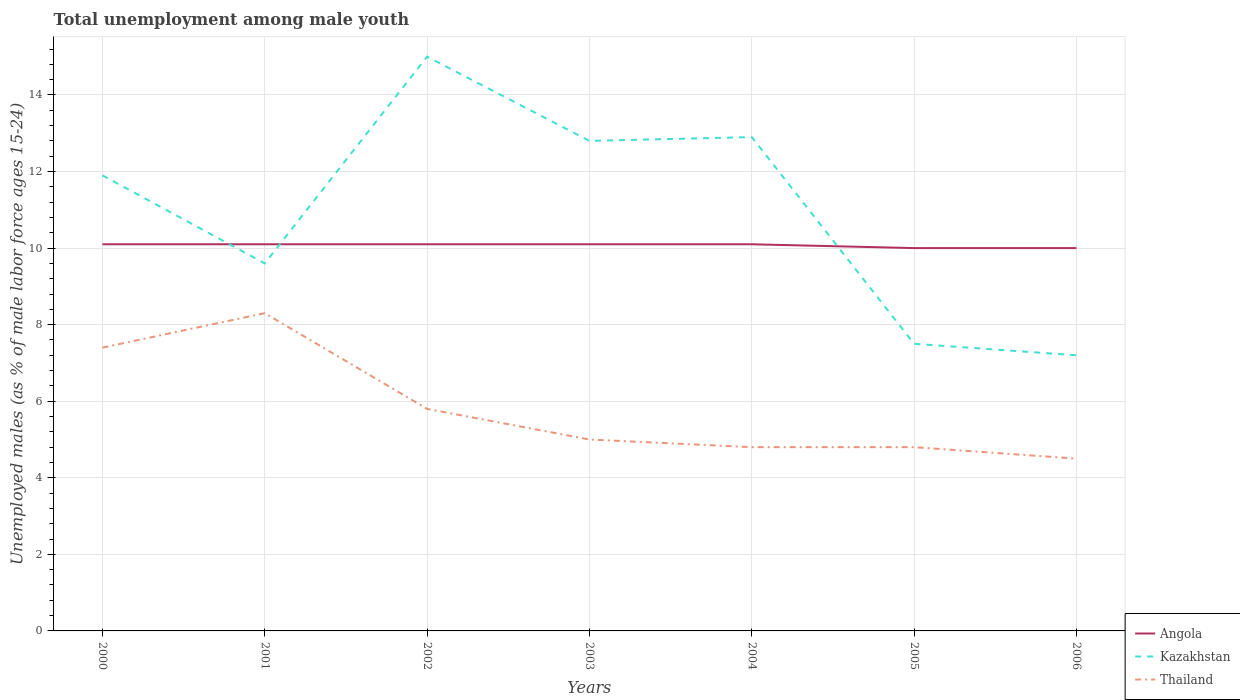How many different coloured lines are there?
Give a very brief answer. 3. Does the line corresponding to Angola intersect with the line corresponding to Thailand?
Your response must be concise. No. What is the total percentage of unemployed males in in Angola in the graph?
Make the answer very short. 0.1. What is the difference between the highest and the second highest percentage of unemployed males in in Kazakhstan?
Make the answer very short. 7.8. What is the difference between the highest and the lowest percentage of unemployed males in in Thailand?
Your answer should be compact. 3. Is the percentage of unemployed males in in Thailand strictly greater than the percentage of unemployed males in in Angola over the years?
Your answer should be very brief. Yes. Are the values on the major ticks of Y-axis written in scientific E-notation?
Ensure brevity in your answer.  No. Does the graph contain any zero values?
Keep it short and to the point. No. How many legend labels are there?
Provide a short and direct response. 3. What is the title of the graph?
Provide a short and direct response. Total unemployment among male youth. What is the label or title of the Y-axis?
Keep it short and to the point. Unemployed males (as % of male labor force ages 15-24). What is the Unemployed males (as % of male labor force ages 15-24) in Angola in 2000?
Offer a very short reply. 10.1. What is the Unemployed males (as % of male labor force ages 15-24) of Kazakhstan in 2000?
Provide a short and direct response. 11.9. What is the Unemployed males (as % of male labor force ages 15-24) in Thailand in 2000?
Provide a succinct answer. 7.4. What is the Unemployed males (as % of male labor force ages 15-24) in Angola in 2001?
Ensure brevity in your answer.  10.1. What is the Unemployed males (as % of male labor force ages 15-24) of Kazakhstan in 2001?
Your answer should be very brief. 9.6. What is the Unemployed males (as % of male labor force ages 15-24) of Thailand in 2001?
Make the answer very short. 8.3. What is the Unemployed males (as % of male labor force ages 15-24) in Angola in 2002?
Keep it short and to the point. 10.1. What is the Unemployed males (as % of male labor force ages 15-24) in Kazakhstan in 2002?
Provide a short and direct response. 15. What is the Unemployed males (as % of male labor force ages 15-24) in Thailand in 2002?
Offer a very short reply. 5.8. What is the Unemployed males (as % of male labor force ages 15-24) of Angola in 2003?
Provide a short and direct response. 10.1. What is the Unemployed males (as % of male labor force ages 15-24) in Kazakhstan in 2003?
Offer a terse response. 12.8. What is the Unemployed males (as % of male labor force ages 15-24) of Angola in 2004?
Provide a succinct answer. 10.1. What is the Unemployed males (as % of male labor force ages 15-24) in Kazakhstan in 2004?
Ensure brevity in your answer.  12.9. What is the Unemployed males (as % of male labor force ages 15-24) of Thailand in 2004?
Give a very brief answer. 4.8. What is the Unemployed males (as % of male labor force ages 15-24) in Thailand in 2005?
Keep it short and to the point. 4.8. What is the Unemployed males (as % of male labor force ages 15-24) of Angola in 2006?
Offer a very short reply. 10. What is the Unemployed males (as % of male labor force ages 15-24) in Kazakhstan in 2006?
Keep it short and to the point. 7.2. Across all years, what is the maximum Unemployed males (as % of male labor force ages 15-24) of Angola?
Offer a terse response. 10.1. Across all years, what is the maximum Unemployed males (as % of male labor force ages 15-24) in Kazakhstan?
Offer a terse response. 15. Across all years, what is the maximum Unemployed males (as % of male labor force ages 15-24) of Thailand?
Your answer should be very brief. 8.3. Across all years, what is the minimum Unemployed males (as % of male labor force ages 15-24) of Angola?
Your answer should be compact. 10. Across all years, what is the minimum Unemployed males (as % of male labor force ages 15-24) in Kazakhstan?
Ensure brevity in your answer.  7.2. Across all years, what is the minimum Unemployed males (as % of male labor force ages 15-24) of Thailand?
Provide a succinct answer. 4.5. What is the total Unemployed males (as % of male labor force ages 15-24) in Angola in the graph?
Make the answer very short. 70.5. What is the total Unemployed males (as % of male labor force ages 15-24) in Kazakhstan in the graph?
Offer a terse response. 76.9. What is the total Unemployed males (as % of male labor force ages 15-24) of Thailand in the graph?
Ensure brevity in your answer.  40.6. What is the difference between the Unemployed males (as % of male labor force ages 15-24) in Angola in 2000 and that in 2001?
Offer a terse response. 0. What is the difference between the Unemployed males (as % of male labor force ages 15-24) in Kazakhstan in 2000 and that in 2001?
Make the answer very short. 2.3. What is the difference between the Unemployed males (as % of male labor force ages 15-24) in Thailand in 2000 and that in 2001?
Give a very brief answer. -0.9. What is the difference between the Unemployed males (as % of male labor force ages 15-24) in Angola in 2000 and that in 2002?
Make the answer very short. 0. What is the difference between the Unemployed males (as % of male labor force ages 15-24) of Thailand in 2000 and that in 2002?
Offer a terse response. 1.6. What is the difference between the Unemployed males (as % of male labor force ages 15-24) in Angola in 2000 and that in 2004?
Provide a short and direct response. 0. What is the difference between the Unemployed males (as % of male labor force ages 15-24) of Kazakhstan in 2000 and that in 2004?
Provide a succinct answer. -1. What is the difference between the Unemployed males (as % of male labor force ages 15-24) in Thailand in 2000 and that in 2005?
Your response must be concise. 2.6. What is the difference between the Unemployed males (as % of male labor force ages 15-24) of Angola in 2001 and that in 2002?
Offer a terse response. 0. What is the difference between the Unemployed males (as % of male labor force ages 15-24) in Thailand in 2001 and that in 2002?
Your answer should be compact. 2.5. What is the difference between the Unemployed males (as % of male labor force ages 15-24) in Angola in 2001 and that in 2003?
Your answer should be compact. 0. What is the difference between the Unemployed males (as % of male labor force ages 15-24) of Kazakhstan in 2001 and that in 2003?
Ensure brevity in your answer.  -3.2. What is the difference between the Unemployed males (as % of male labor force ages 15-24) of Angola in 2001 and that in 2004?
Your response must be concise. 0. What is the difference between the Unemployed males (as % of male labor force ages 15-24) in Angola in 2001 and that in 2005?
Your answer should be very brief. 0.1. What is the difference between the Unemployed males (as % of male labor force ages 15-24) of Thailand in 2001 and that in 2005?
Offer a very short reply. 3.5. What is the difference between the Unemployed males (as % of male labor force ages 15-24) in Angola in 2001 and that in 2006?
Make the answer very short. 0.1. What is the difference between the Unemployed males (as % of male labor force ages 15-24) in Kazakhstan in 2001 and that in 2006?
Ensure brevity in your answer.  2.4. What is the difference between the Unemployed males (as % of male labor force ages 15-24) of Kazakhstan in 2002 and that in 2003?
Your response must be concise. 2.2. What is the difference between the Unemployed males (as % of male labor force ages 15-24) in Thailand in 2002 and that in 2003?
Keep it short and to the point. 0.8. What is the difference between the Unemployed males (as % of male labor force ages 15-24) in Angola in 2002 and that in 2005?
Provide a short and direct response. 0.1. What is the difference between the Unemployed males (as % of male labor force ages 15-24) in Kazakhstan in 2002 and that in 2006?
Your answer should be compact. 7.8. What is the difference between the Unemployed males (as % of male labor force ages 15-24) of Thailand in 2003 and that in 2004?
Your answer should be compact. 0.2. What is the difference between the Unemployed males (as % of male labor force ages 15-24) of Kazakhstan in 2003 and that in 2005?
Give a very brief answer. 5.3. What is the difference between the Unemployed males (as % of male labor force ages 15-24) of Angola in 2003 and that in 2006?
Make the answer very short. 0.1. What is the difference between the Unemployed males (as % of male labor force ages 15-24) in Kazakhstan in 2003 and that in 2006?
Make the answer very short. 5.6. What is the difference between the Unemployed males (as % of male labor force ages 15-24) of Kazakhstan in 2004 and that in 2006?
Your answer should be compact. 5.7. What is the difference between the Unemployed males (as % of male labor force ages 15-24) of Thailand in 2004 and that in 2006?
Provide a succinct answer. 0.3. What is the difference between the Unemployed males (as % of male labor force ages 15-24) in Thailand in 2005 and that in 2006?
Offer a terse response. 0.3. What is the difference between the Unemployed males (as % of male labor force ages 15-24) of Angola in 2000 and the Unemployed males (as % of male labor force ages 15-24) of Kazakhstan in 2001?
Make the answer very short. 0.5. What is the difference between the Unemployed males (as % of male labor force ages 15-24) in Angola in 2000 and the Unemployed males (as % of male labor force ages 15-24) in Thailand in 2002?
Offer a terse response. 4.3. What is the difference between the Unemployed males (as % of male labor force ages 15-24) of Kazakhstan in 2000 and the Unemployed males (as % of male labor force ages 15-24) of Thailand in 2003?
Your answer should be compact. 6.9. What is the difference between the Unemployed males (as % of male labor force ages 15-24) of Kazakhstan in 2000 and the Unemployed males (as % of male labor force ages 15-24) of Thailand in 2004?
Provide a succinct answer. 7.1. What is the difference between the Unemployed males (as % of male labor force ages 15-24) in Angola in 2000 and the Unemployed males (as % of male labor force ages 15-24) in Kazakhstan in 2005?
Make the answer very short. 2.6. What is the difference between the Unemployed males (as % of male labor force ages 15-24) in Kazakhstan in 2000 and the Unemployed males (as % of male labor force ages 15-24) in Thailand in 2005?
Your answer should be very brief. 7.1. What is the difference between the Unemployed males (as % of male labor force ages 15-24) in Angola in 2000 and the Unemployed males (as % of male labor force ages 15-24) in Thailand in 2006?
Offer a very short reply. 5.6. What is the difference between the Unemployed males (as % of male labor force ages 15-24) of Angola in 2001 and the Unemployed males (as % of male labor force ages 15-24) of Kazakhstan in 2002?
Your response must be concise. -4.9. What is the difference between the Unemployed males (as % of male labor force ages 15-24) in Kazakhstan in 2001 and the Unemployed males (as % of male labor force ages 15-24) in Thailand in 2002?
Your response must be concise. 3.8. What is the difference between the Unemployed males (as % of male labor force ages 15-24) in Angola in 2001 and the Unemployed males (as % of male labor force ages 15-24) in Kazakhstan in 2003?
Provide a short and direct response. -2.7. What is the difference between the Unemployed males (as % of male labor force ages 15-24) of Angola in 2001 and the Unemployed males (as % of male labor force ages 15-24) of Thailand in 2003?
Ensure brevity in your answer.  5.1. What is the difference between the Unemployed males (as % of male labor force ages 15-24) of Kazakhstan in 2001 and the Unemployed males (as % of male labor force ages 15-24) of Thailand in 2003?
Offer a very short reply. 4.6. What is the difference between the Unemployed males (as % of male labor force ages 15-24) in Angola in 2001 and the Unemployed males (as % of male labor force ages 15-24) in Kazakhstan in 2004?
Your response must be concise. -2.8. What is the difference between the Unemployed males (as % of male labor force ages 15-24) of Kazakhstan in 2001 and the Unemployed males (as % of male labor force ages 15-24) of Thailand in 2004?
Your answer should be compact. 4.8. What is the difference between the Unemployed males (as % of male labor force ages 15-24) in Kazakhstan in 2001 and the Unemployed males (as % of male labor force ages 15-24) in Thailand in 2005?
Provide a short and direct response. 4.8. What is the difference between the Unemployed males (as % of male labor force ages 15-24) of Angola in 2001 and the Unemployed males (as % of male labor force ages 15-24) of Thailand in 2006?
Provide a succinct answer. 5.6. What is the difference between the Unemployed males (as % of male labor force ages 15-24) in Kazakhstan in 2001 and the Unemployed males (as % of male labor force ages 15-24) in Thailand in 2006?
Provide a succinct answer. 5.1. What is the difference between the Unemployed males (as % of male labor force ages 15-24) of Angola in 2002 and the Unemployed males (as % of male labor force ages 15-24) of Kazakhstan in 2004?
Provide a succinct answer. -2.8. What is the difference between the Unemployed males (as % of male labor force ages 15-24) of Angola in 2002 and the Unemployed males (as % of male labor force ages 15-24) of Thailand in 2005?
Make the answer very short. 5.3. What is the difference between the Unemployed males (as % of male labor force ages 15-24) of Kazakhstan in 2002 and the Unemployed males (as % of male labor force ages 15-24) of Thailand in 2005?
Your answer should be very brief. 10.2. What is the difference between the Unemployed males (as % of male labor force ages 15-24) of Angola in 2003 and the Unemployed males (as % of male labor force ages 15-24) of Thailand in 2004?
Provide a succinct answer. 5.3. What is the difference between the Unemployed males (as % of male labor force ages 15-24) in Kazakhstan in 2003 and the Unemployed males (as % of male labor force ages 15-24) in Thailand in 2004?
Your answer should be very brief. 8. What is the difference between the Unemployed males (as % of male labor force ages 15-24) of Angola in 2003 and the Unemployed males (as % of male labor force ages 15-24) of Kazakhstan in 2005?
Ensure brevity in your answer.  2.6. What is the difference between the Unemployed males (as % of male labor force ages 15-24) in Kazakhstan in 2003 and the Unemployed males (as % of male labor force ages 15-24) in Thailand in 2005?
Offer a terse response. 8. What is the difference between the Unemployed males (as % of male labor force ages 15-24) in Angola in 2003 and the Unemployed males (as % of male labor force ages 15-24) in Thailand in 2006?
Provide a succinct answer. 5.6. What is the difference between the Unemployed males (as % of male labor force ages 15-24) of Angola in 2004 and the Unemployed males (as % of male labor force ages 15-24) of Kazakhstan in 2005?
Your answer should be very brief. 2.6. What is the difference between the Unemployed males (as % of male labor force ages 15-24) in Angola in 2004 and the Unemployed males (as % of male labor force ages 15-24) in Thailand in 2005?
Ensure brevity in your answer.  5.3. What is the difference between the Unemployed males (as % of male labor force ages 15-24) of Kazakhstan in 2004 and the Unemployed males (as % of male labor force ages 15-24) of Thailand in 2005?
Ensure brevity in your answer.  8.1. What is the difference between the Unemployed males (as % of male labor force ages 15-24) in Angola in 2004 and the Unemployed males (as % of male labor force ages 15-24) in Kazakhstan in 2006?
Provide a succinct answer. 2.9. What is the difference between the Unemployed males (as % of male labor force ages 15-24) in Angola in 2004 and the Unemployed males (as % of male labor force ages 15-24) in Thailand in 2006?
Make the answer very short. 5.6. What is the difference between the Unemployed males (as % of male labor force ages 15-24) of Angola in 2005 and the Unemployed males (as % of male labor force ages 15-24) of Thailand in 2006?
Offer a terse response. 5.5. What is the average Unemployed males (as % of male labor force ages 15-24) of Angola per year?
Keep it short and to the point. 10.07. What is the average Unemployed males (as % of male labor force ages 15-24) in Kazakhstan per year?
Give a very brief answer. 10.99. What is the average Unemployed males (as % of male labor force ages 15-24) of Thailand per year?
Offer a very short reply. 5.8. In the year 2000, what is the difference between the Unemployed males (as % of male labor force ages 15-24) in Angola and Unemployed males (as % of male labor force ages 15-24) in Kazakhstan?
Keep it short and to the point. -1.8. In the year 2000, what is the difference between the Unemployed males (as % of male labor force ages 15-24) in Angola and Unemployed males (as % of male labor force ages 15-24) in Thailand?
Provide a succinct answer. 2.7. In the year 2001, what is the difference between the Unemployed males (as % of male labor force ages 15-24) in Angola and Unemployed males (as % of male labor force ages 15-24) in Kazakhstan?
Provide a short and direct response. 0.5. In the year 2001, what is the difference between the Unemployed males (as % of male labor force ages 15-24) in Kazakhstan and Unemployed males (as % of male labor force ages 15-24) in Thailand?
Offer a terse response. 1.3. In the year 2002, what is the difference between the Unemployed males (as % of male labor force ages 15-24) of Kazakhstan and Unemployed males (as % of male labor force ages 15-24) of Thailand?
Ensure brevity in your answer.  9.2. In the year 2003, what is the difference between the Unemployed males (as % of male labor force ages 15-24) in Angola and Unemployed males (as % of male labor force ages 15-24) in Thailand?
Give a very brief answer. 5.1. In the year 2004, what is the difference between the Unemployed males (as % of male labor force ages 15-24) of Angola and Unemployed males (as % of male labor force ages 15-24) of Kazakhstan?
Ensure brevity in your answer.  -2.8. In the year 2004, what is the difference between the Unemployed males (as % of male labor force ages 15-24) in Angola and Unemployed males (as % of male labor force ages 15-24) in Thailand?
Offer a very short reply. 5.3. In the year 2004, what is the difference between the Unemployed males (as % of male labor force ages 15-24) of Kazakhstan and Unemployed males (as % of male labor force ages 15-24) of Thailand?
Your response must be concise. 8.1. In the year 2005, what is the difference between the Unemployed males (as % of male labor force ages 15-24) in Angola and Unemployed males (as % of male labor force ages 15-24) in Kazakhstan?
Offer a terse response. 2.5. In the year 2005, what is the difference between the Unemployed males (as % of male labor force ages 15-24) in Kazakhstan and Unemployed males (as % of male labor force ages 15-24) in Thailand?
Offer a very short reply. 2.7. In the year 2006, what is the difference between the Unemployed males (as % of male labor force ages 15-24) in Angola and Unemployed males (as % of male labor force ages 15-24) in Kazakhstan?
Your response must be concise. 2.8. In the year 2006, what is the difference between the Unemployed males (as % of male labor force ages 15-24) of Angola and Unemployed males (as % of male labor force ages 15-24) of Thailand?
Provide a short and direct response. 5.5. In the year 2006, what is the difference between the Unemployed males (as % of male labor force ages 15-24) in Kazakhstan and Unemployed males (as % of male labor force ages 15-24) in Thailand?
Provide a short and direct response. 2.7. What is the ratio of the Unemployed males (as % of male labor force ages 15-24) in Angola in 2000 to that in 2001?
Your answer should be very brief. 1. What is the ratio of the Unemployed males (as % of male labor force ages 15-24) in Kazakhstan in 2000 to that in 2001?
Offer a very short reply. 1.24. What is the ratio of the Unemployed males (as % of male labor force ages 15-24) of Thailand in 2000 to that in 2001?
Provide a succinct answer. 0.89. What is the ratio of the Unemployed males (as % of male labor force ages 15-24) in Kazakhstan in 2000 to that in 2002?
Give a very brief answer. 0.79. What is the ratio of the Unemployed males (as % of male labor force ages 15-24) in Thailand in 2000 to that in 2002?
Your response must be concise. 1.28. What is the ratio of the Unemployed males (as % of male labor force ages 15-24) in Kazakhstan in 2000 to that in 2003?
Your response must be concise. 0.93. What is the ratio of the Unemployed males (as % of male labor force ages 15-24) of Thailand in 2000 to that in 2003?
Offer a terse response. 1.48. What is the ratio of the Unemployed males (as % of male labor force ages 15-24) of Kazakhstan in 2000 to that in 2004?
Keep it short and to the point. 0.92. What is the ratio of the Unemployed males (as % of male labor force ages 15-24) of Thailand in 2000 to that in 2004?
Make the answer very short. 1.54. What is the ratio of the Unemployed males (as % of male labor force ages 15-24) in Kazakhstan in 2000 to that in 2005?
Give a very brief answer. 1.59. What is the ratio of the Unemployed males (as % of male labor force ages 15-24) of Thailand in 2000 to that in 2005?
Your answer should be very brief. 1.54. What is the ratio of the Unemployed males (as % of male labor force ages 15-24) of Kazakhstan in 2000 to that in 2006?
Offer a terse response. 1.65. What is the ratio of the Unemployed males (as % of male labor force ages 15-24) in Thailand in 2000 to that in 2006?
Ensure brevity in your answer.  1.64. What is the ratio of the Unemployed males (as % of male labor force ages 15-24) in Angola in 2001 to that in 2002?
Keep it short and to the point. 1. What is the ratio of the Unemployed males (as % of male labor force ages 15-24) in Kazakhstan in 2001 to that in 2002?
Offer a very short reply. 0.64. What is the ratio of the Unemployed males (as % of male labor force ages 15-24) in Thailand in 2001 to that in 2002?
Make the answer very short. 1.43. What is the ratio of the Unemployed males (as % of male labor force ages 15-24) of Thailand in 2001 to that in 2003?
Offer a terse response. 1.66. What is the ratio of the Unemployed males (as % of male labor force ages 15-24) of Kazakhstan in 2001 to that in 2004?
Your answer should be compact. 0.74. What is the ratio of the Unemployed males (as % of male labor force ages 15-24) of Thailand in 2001 to that in 2004?
Ensure brevity in your answer.  1.73. What is the ratio of the Unemployed males (as % of male labor force ages 15-24) in Kazakhstan in 2001 to that in 2005?
Your answer should be very brief. 1.28. What is the ratio of the Unemployed males (as % of male labor force ages 15-24) of Thailand in 2001 to that in 2005?
Provide a short and direct response. 1.73. What is the ratio of the Unemployed males (as % of male labor force ages 15-24) in Angola in 2001 to that in 2006?
Ensure brevity in your answer.  1.01. What is the ratio of the Unemployed males (as % of male labor force ages 15-24) of Thailand in 2001 to that in 2006?
Your answer should be very brief. 1.84. What is the ratio of the Unemployed males (as % of male labor force ages 15-24) of Angola in 2002 to that in 2003?
Offer a very short reply. 1. What is the ratio of the Unemployed males (as % of male labor force ages 15-24) of Kazakhstan in 2002 to that in 2003?
Your answer should be compact. 1.17. What is the ratio of the Unemployed males (as % of male labor force ages 15-24) in Thailand in 2002 to that in 2003?
Ensure brevity in your answer.  1.16. What is the ratio of the Unemployed males (as % of male labor force ages 15-24) in Kazakhstan in 2002 to that in 2004?
Your response must be concise. 1.16. What is the ratio of the Unemployed males (as % of male labor force ages 15-24) of Thailand in 2002 to that in 2004?
Offer a very short reply. 1.21. What is the ratio of the Unemployed males (as % of male labor force ages 15-24) of Kazakhstan in 2002 to that in 2005?
Offer a terse response. 2. What is the ratio of the Unemployed males (as % of male labor force ages 15-24) of Thailand in 2002 to that in 2005?
Ensure brevity in your answer.  1.21. What is the ratio of the Unemployed males (as % of male labor force ages 15-24) in Angola in 2002 to that in 2006?
Keep it short and to the point. 1.01. What is the ratio of the Unemployed males (as % of male labor force ages 15-24) in Kazakhstan in 2002 to that in 2006?
Give a very brief answer. 2.08. What is the ratio of the Unemployed males (as % of male labor force ages 15-24) of Thailand in 2002 to that in 2006?
Provide a short and direct response. 1.29. What is the ratio of the Unemployed males (as % of male labor force ages 15-24) of Angola in 2003 to that in 2004?
Keep it short and to the point. 1. What is the ratio of the Unemployed males (as % of male labor force ages 15-24) in Thailand in 2003 to that in 2004?
Keep it short and to the point. 1.04. What is the ratio of the Unemployed males (as % of male labor force ages 15-24) of Kazakhstan in 2003 to that in 2005?
Ensure brevity in your answer.  1.71. What is the ratio of the Unemployed males (as % of male labor force ages 15-24) of Thailand in 2003 to that in 2005?
Your answer should be very brief. 1.04. What is the ratio of the Unemployed males (as % of male labor force ages 15-24) of Kazakhstan in 2003 to that in 2006?
Offer a very short reply. 1.78. What is the ratio of the Unemployed males (as % of male labor force ages 15-24) of Kazakhstan in 2004 to that in 2005?
Keep it short and to the point. 1.72. What is the ratio of the Unemployed males (as % of male labor force ages 15-24) of Angola in 2004 to that in 2006?
Provide a short and direct response. 1.01. What is the ratio of the Unemployed males (as % of male labor force ages 15-24) in Kazakhstan in 2004 to that in 2006?
Keep it short and to the point. 1.79. What is the ratio of the Unemployed males (as % of male labor force ages 15-24) of Thailand in 2004 to that in 2006?
Your answer should be compact. 1.07. What is the ratio of the Unemployed males (as % of male labor force ages 15-24) of Angola in 2005 to that in 2006?
Offer a terse response. 1. What is the ratio of the Unemployed males (as % of male labor force ages 15-24) in Kazakhstan in 2005 to that in 2006?
Provide a short and direct response. 1.04. What is the ratio of the Unemployed males (as % of male labor force ages 15-24) in Thailand in 2005 to that in 2006?
Give a very brief answer. 1.07. What is the difference between the highest and the second highest Unemployed males (as % of male labor force ages 15-24) in Angola?
Your answer should be very brief. 0. What is the difference between the highest and the lowest Unemployed males (as % of male labor force ages 15-24) of Thailand?
Offer a terse response. 3.8. 